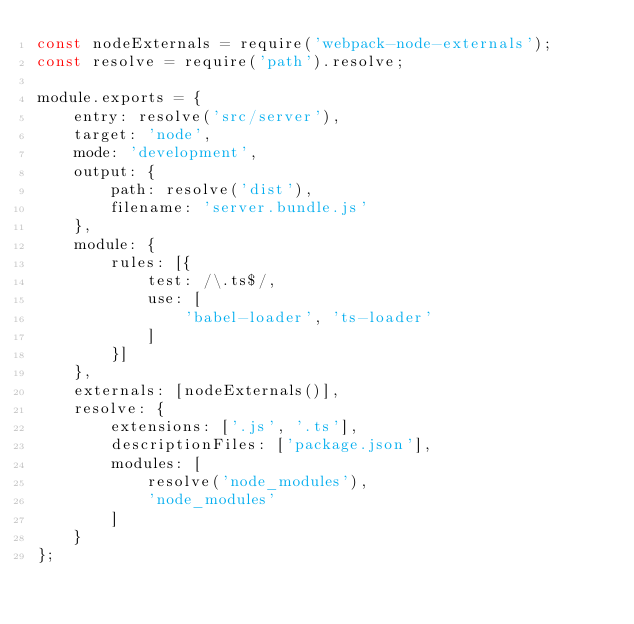<code> <loc_0><loc_0><loc_500><loc_500><_JavaScript_>const nodeExternals = require('webpack-node-externals');
const resolve = require('path').resolve;

module.exports = {
    entry: resolve('src/server'),
    target: 'node',
    mode: 'development',
    output: {
        path: resolve('dist'),
        filename: 'server.bundle.js'
    },
    module: {
        rules: [{
            test: /\.ts$/,
            use: [
                'babel-loader', 'ts-loader'
            ]
        }]
    },
    externals: [nodeExternals()],
    resolve: {
        extensions: ['.js', '.ts'],
        descriptionFiles: ['package.json'],
        modules: [
            resolve('node_modules'),
            'node_modules'
        ]
    }
};</code> 